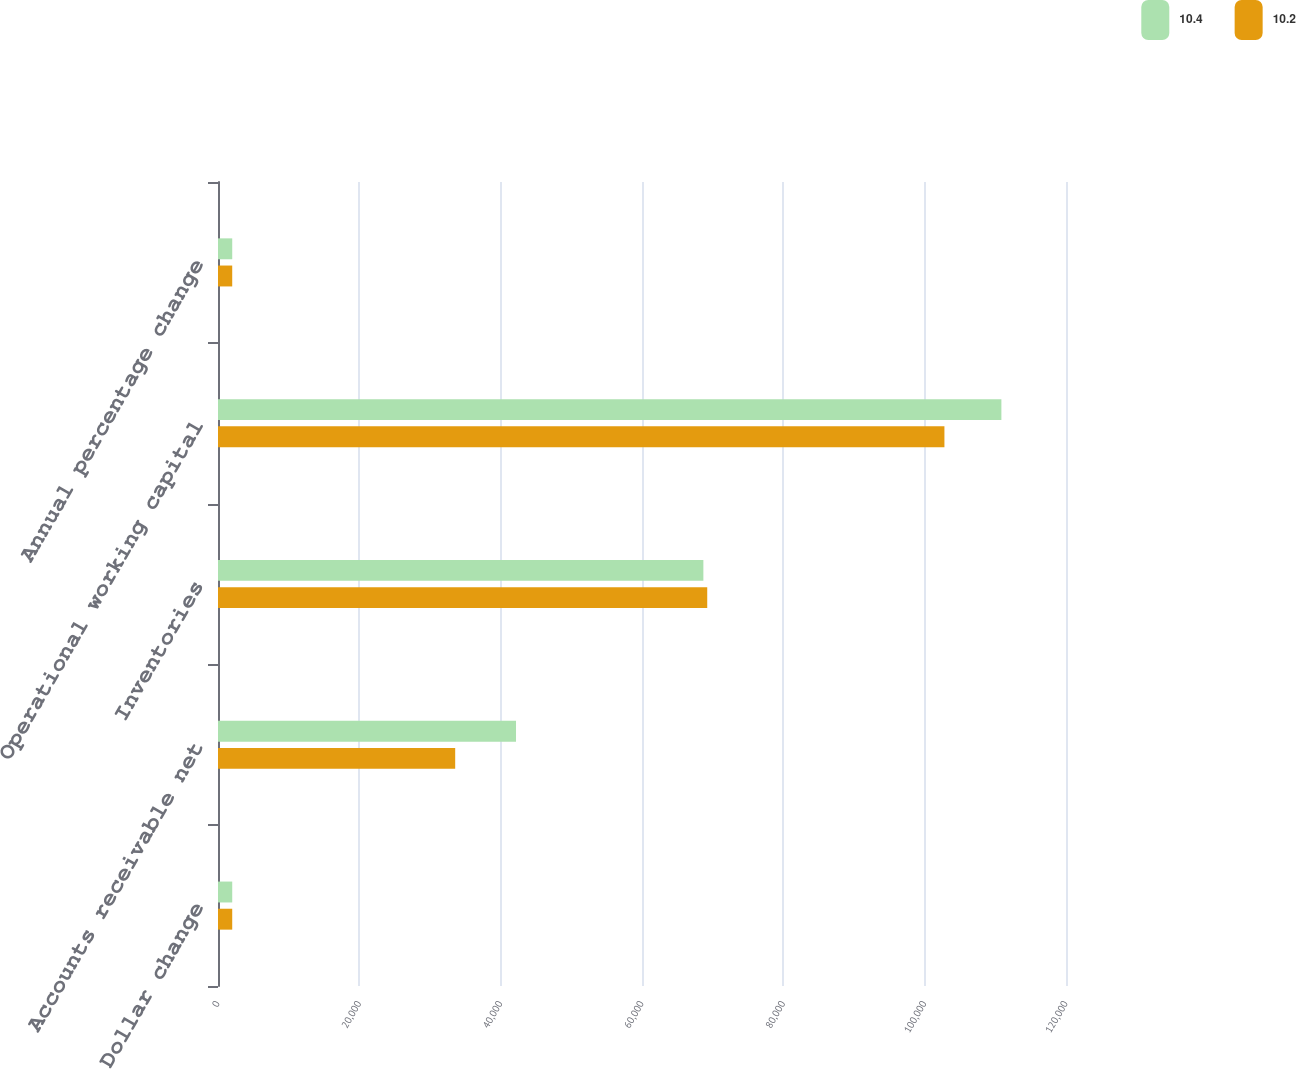Convert chart. <chart><loc_0><loc_0><loc_500><loc_500><stacked_bar_chart><ecel><fcel>Dollar change<fcel>Accounts receivable net<fcel>Inventories<fcel>Operational working capital<fcel>Annual percentage change<nl><fcel>10.4<fcel>2013<fcel>42172<fcel>68685<fcel>110857<fcel>2013<nl><fcel>10.2<fcel>2012<fcel>33565<fcel>69231<fcel>102796<fcel>2012<nl></chart> 